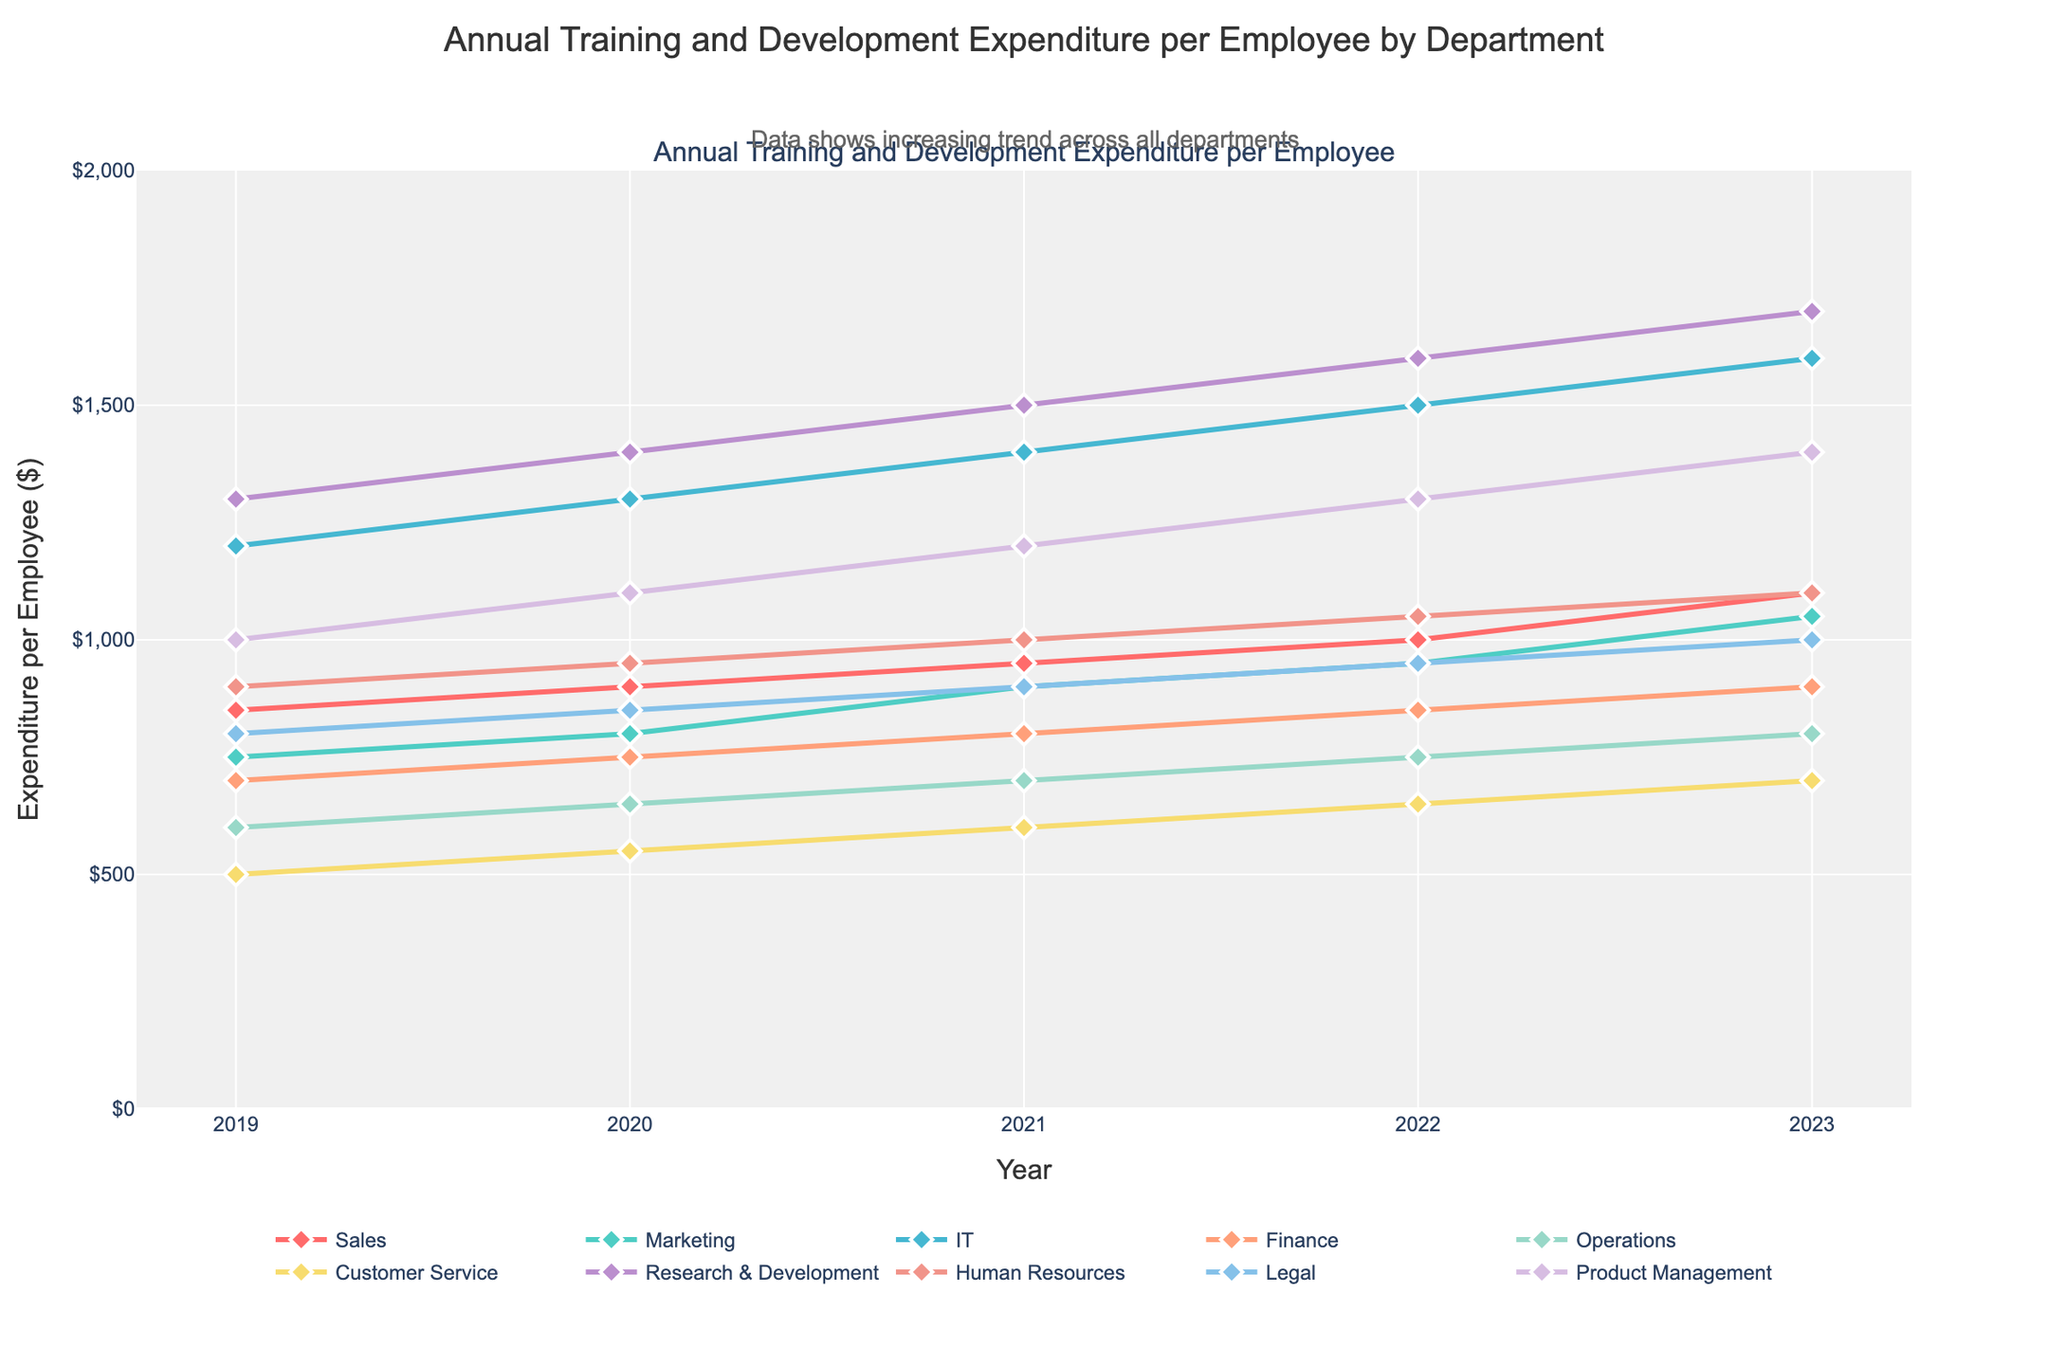What's the trend in training expenditure for the Sales department from 2019 to 2023? From the figure, observe the line representing the Sales department. The expenditure has increased year over year from $850 in 2019 to $1100 in 2023.
Answer: Increasing Which department had the highest expenditure in 2023? Locate the lines at the far-right end of the plot (year 2023). The department with the highest point is Research & Development at $1700.
Answer: Research & Development What was the expenditure difference between the IT and Finance departments in 2022? Find the expenditure for both the IT and Finance departments in 2022. IT spent $1500, while Finance spent $850. Subtract $850 from $1500 to get $650.
Answer: $650 How does the expenditure of Customer Service compare to Human Resources in 2020? In 2020, Customer Service expenditure was $550 and Human Resources was $950. Comparing them, Customer Service spent $400 less than Human Resources.
Answer: $400 less Which departments have shown a consistent increase year-over-year? Inspect the trend lines for each department. Sales, Marketing, IT, Finance, Operations, Customer Service, Research & Development, Human Resources, Legal, and Product Management all show a consistent upward trend every year.
Answer: All departments What's the total training expenditure for the Product Management department from 2019 to 2023? Add the expenditures for the Product Management department from each year: $1000 (2019) + $1100 (2020) + $1200 (2021) + $1300 (2022) + $1400 (2023) = $6000.
Answer: $6000 Which department showed the most significant increase in expenditure between 2019 and 2023? Compare the difference in expenditures for each department between 2019 and 2023. Research & Development increased by the largest amount from $1300 to $1700, an increase of $400.
Answer: Research & Development Has the Marketing department ever outspent Product Management between 2019 and 2023? Review the expenditure lines for Marketing and Product Management. Marketing ($750-$1050) never surpasses Product Management ($1000-$1400) at any point.
Answer: No How did the expenditure for Legal change from 2019 to 2021? Look at Legal's line from 2019 ($800), 2020 ($850), and 2021 ($900). The expenditure increased by $100 over these three years.
Answer: Increased by $100 